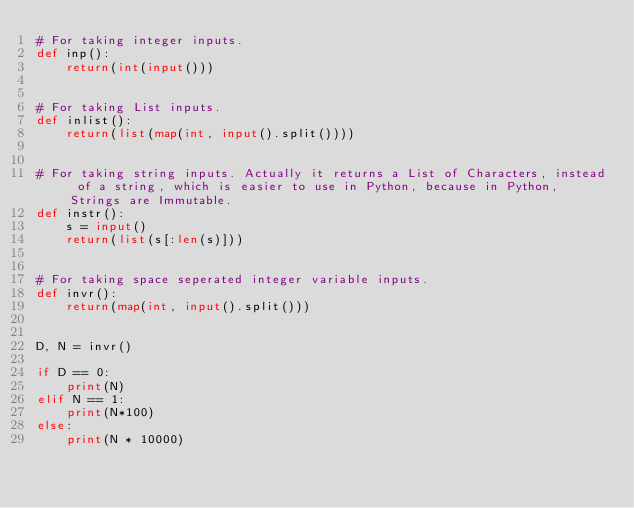<code> <loc_0><loc_0><loc_500><loc_500><_Python_># For taking integer inputs.
def inp():
    return(int(input()))


# For taking List inputs.
def inlist():
    return(list(map(int, input().split())))


# For taking string inputs. Actually it returns a List of Characters, instead of a string, which is easier to use in Python, because in Python, Strings are Immutable.
def instr():
    s = input()
    return(list(s[:len(s)]))


# For taking space seperated integer variable inputs.
def invr():
    return(map(int, input().split()))


D, N = invr()

if D == 0:
    print(N)
elif N == 1:
    print(N*100)
else:
    print(N * 10000)
</code> 